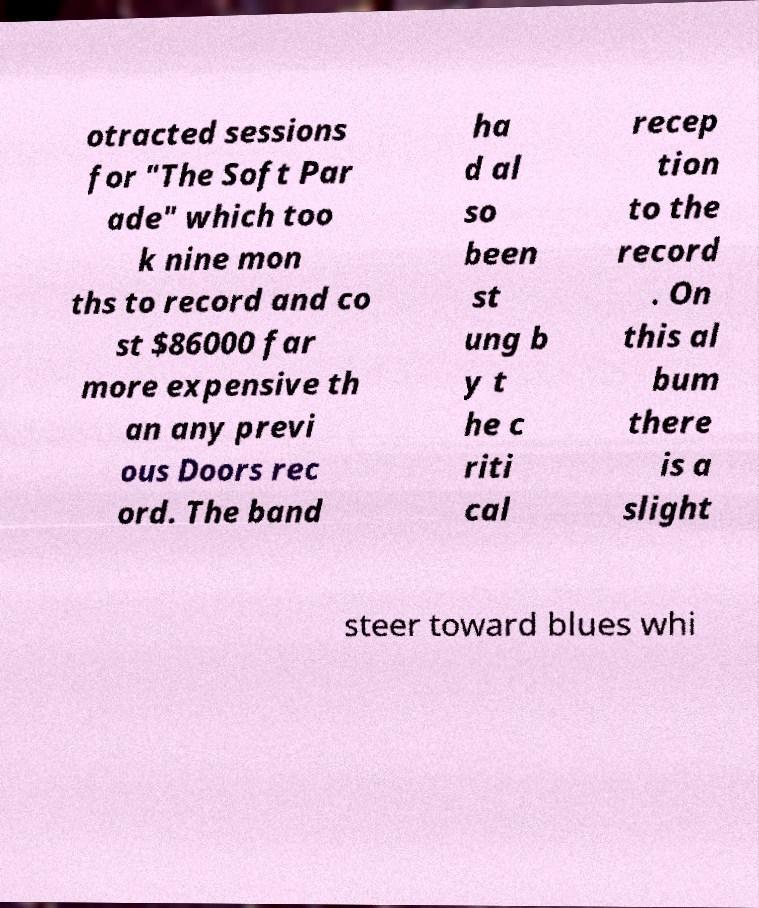What messages or text are displayed in this image? I need them in a readable, typed format. otracted sessions for "The Soft Par ade" which too k nine mon ths to record and co st $86000 far more expensive th an any previ ous Doors rec ord. The band ha d al so been st ung b y t he c riti cal recep tion to the record . On this al bum there is a slight steer toward blues whi 